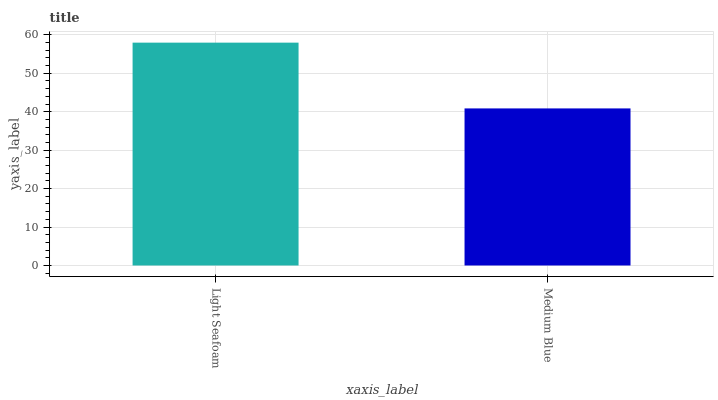Is Medium Blue the minimum?
Answer yes or no. Yes. Is Light Seafoam the maximum?
Answer yes or no. Yes. Is Medium Blue the maximum?
Answer yes or no. No. Is Light Seafoam greater than Medium Blue?
Answer yes or no. Yes. Is Medium Blue less than Light Seafoam?
Answer yes or no. Yes. Is Medium Blue greater than Light Seafoam?
Answer yes or no. No. Is Light Seafoam less than Medium Blue?
Answer yes or no. No. Is Light Seafoam the high median?
Answer yes or no. Yes. Is Medium Blue the low median?
Answer yes or no. Yes. Is Medium Blue the high median?
Answer yes or no. No. Is Light Seafoam the low median?
Answer yes or no. No. 